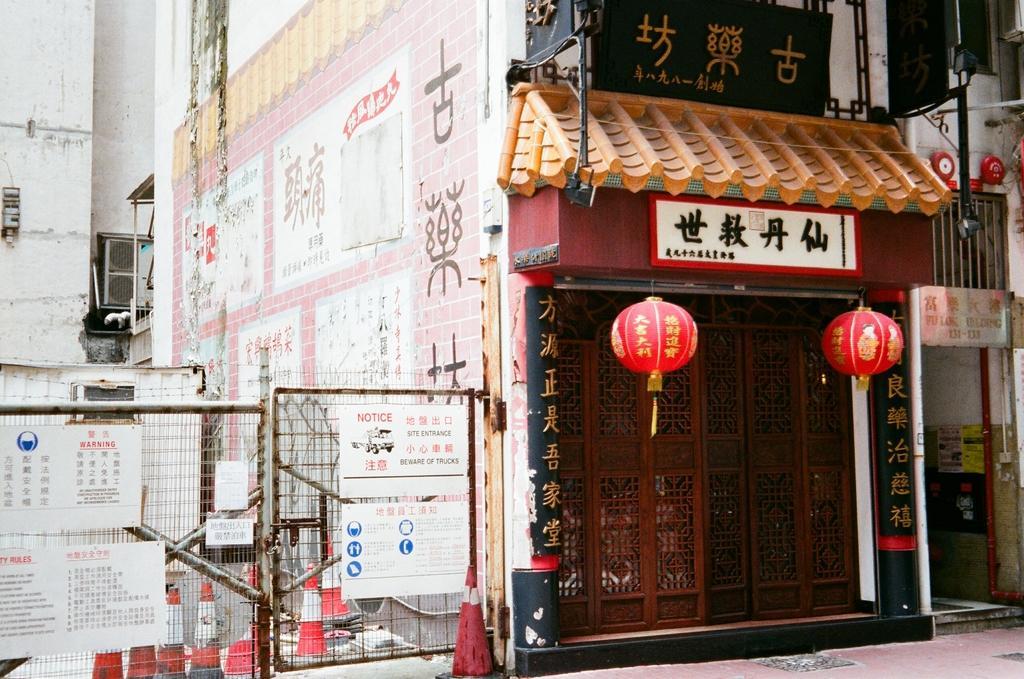Could you give a brief overview of what you see in this image? In this picture we can see the buildings. On the right we can see the doors and sign boards. On the left we can see many traffic cones near to the gate and fencing. On that fencing we can see the posters. 